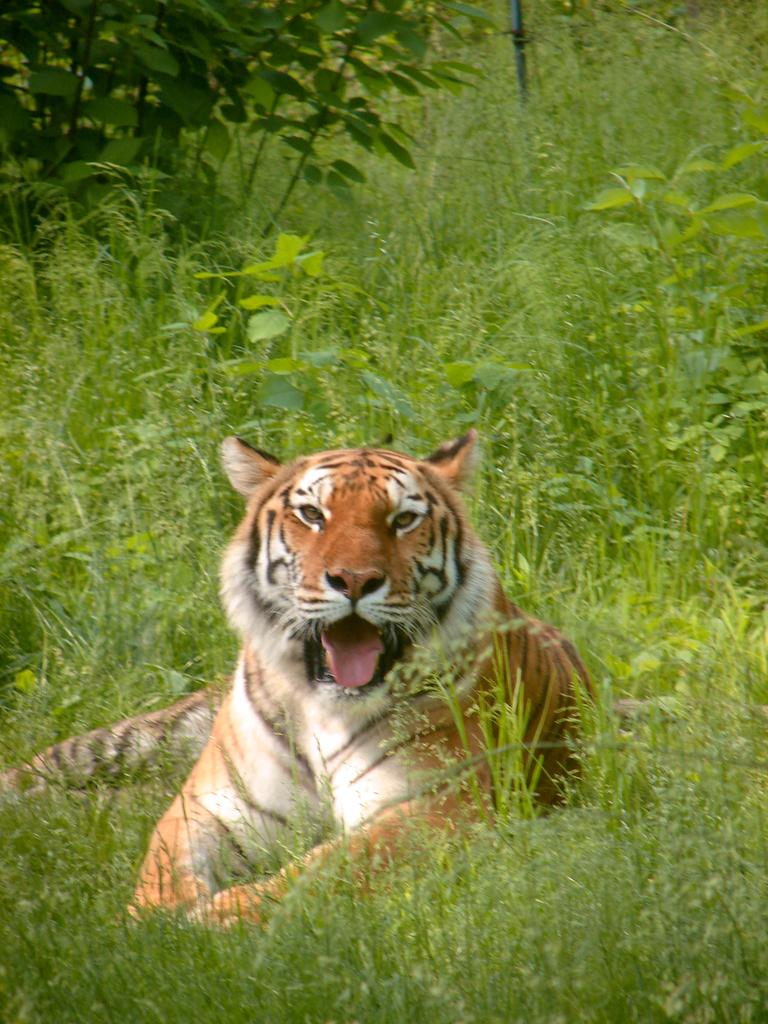What animal is in the image? There is a tiger in the image. What is the tiger doing in the image? The tiger is lying on the ground. What can be seen in the background of the image? There is grass and plants in the background of the image. What color is the silver lamp in the image? There is no silver lamp present in the image. 